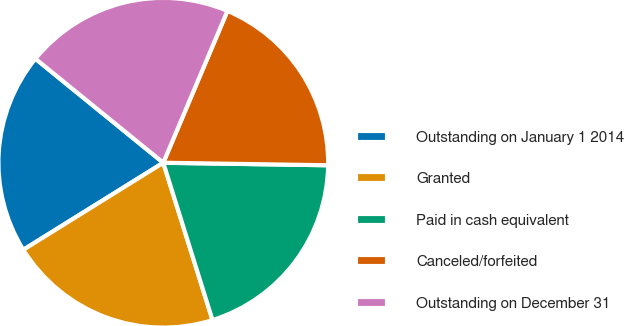<chart> <loc_0><loc_0><loc_500><loc_500><pie_chart><fcel>Outstanding on January 1 2014<fcel>Granted<fcel>Paid in cash equivalent<fcel>Canceled/forfeited<fcel>Outstanding on December 31<nl><fcel>19.72%<fcel>20.97%<fcel>19.93%<fcel>18.88%<fcel>20.49%<nl></chart> 